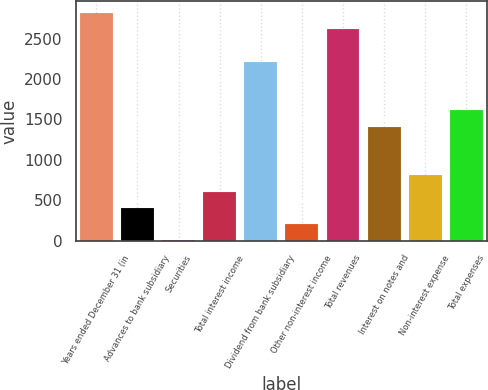Convert chart to OTSL. <chart><loc_0><loc_0><loc_500><loc_500><bar_chart><fcel>Years ended December 31 (in<fcel>Advances to bank subsidiary<fcel>Securities<fcel>Total interest income<fcel>Dividend from bank subsidiary<fcel>Other non-interest income<fcel>Total revenues<fcel>Interest on notes and<fcel>Non-interest expense<fcel>Total expenses<nl><fcel>2819.44<fcel>403.12<fcel>0.4<fcel>604.48<fcel>2215.36<fcel>201.76<fcel>2618.08<fcel>1409.92<fcel>805.84<fcel>1611.28<nl></chart> 